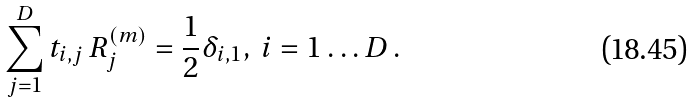Convert formula to latex. <formula><loc_0><loc_0><loc_500><loc_500>\sum _ { j = 1 } ^ { D } t _ { i , j } \, R ^ { ( m ) } _ { j } = \frac { 1 } { 2 } \delta _ { i , 1 } , \, i = 1 \dots D \, .</formula> 